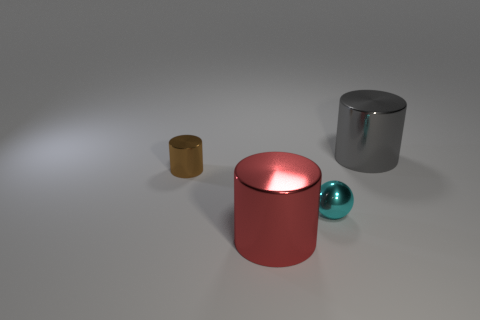What is the shape of the big metal object that is on the right side of the large metal object that is to the left of the big object behind the red object?
Your answer should be very brief. Cylinder. What number of other things are the same shape as the brown thing?
Provide a short and direct response. 2. Is the big red cylinder made of the same material as the brown object?
Give a very brief answer. Yes. There is a big metal cylinder that is on the right side of the big shiny cylinder in front of the large gray metallic cylinder; what number of large gray cylinders are right of it?
Keep it short and to the point. 0. Is there a cyan thing made of the same material as the brown cylinder?
Keep it short and to the point. Yes. Are there fewer big green metallic cubes than gray shiny cylinders?
Keep it short and to the point. Yes. What is the material of the cylinder that is right of the big object on the left side of the shiny cylinder behind the tiny brown metal cylinder?
Offer a terse response. Metal. Is the number of cyan things in front of the small cyan metallic thing less than the number of small cyan things?
Provide a succinct answer. Yes. Is the size of the cyan object that is in front of the gray thing the same as the red cylinder?
Your answer should be compact. No. How many metallic cylinders are on the left side of the gray shiny object and behind the brown metallic cylinder?
Make the answer very short. 0. 